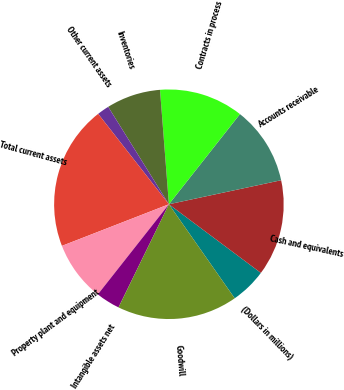Convert chart. <chart><loc_0><loc_0><loc_500><loc_500><pie_chart><fcel>(Dollars in millions)<fcel>Cash and equivalents<fcel>Accounts receivable<fcel>Contracts in process<fcel>Inventories<fcel>Other current assets<fcel>Total current assets<fcel>Property plant and equipment<fcel>Intangible assets net<fcel>Goodwill<nl><fcel>5.08%<fcel>13.56%<fcel>11.02%<fcel>11.86%<fcel>7.63%<fcel>1.7%<fcel>20.34%<fcel>8.47%<fcel>3.39%<fcel>16.95%<nl></chart> 